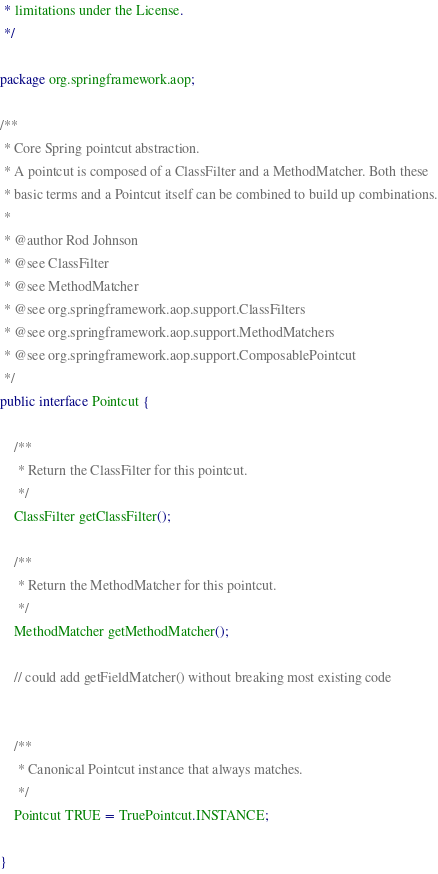<code> <loc_0><loc_0><loc_500><loc_500><_Java_> * limitations under the License.
 */

package org.springframework.aop;

/**
 * Core Spring pointcut abstraction.
 * A pointcut is composed of a ClassFilter and a MethodMatcher. Both these
 * basic terms and a Pointcut itself can be combined to build up combinations.
 *
 * @author Rod Johnson
 * @see ClassFilter
 * @see MethodMatcher
 * @see org.springframework.aop.support.ClassFilters
 * @see org.springframework.aop.support.MethodMatchers
 * @see org.springframework.aop.support.ComposablePointcut
 */
public interface Pointcut {

	/**
	 * Return the ClassFilter for this pointcut.
	 */
	ClassFilter getClassFilter();

	/**
	 * Return the MethodMatcher for this pointcut.
	 */
	MethodMatcher getMethodMatcher();

	// could add getFieldMatcher() without breaking most existing code


	/**
	 * Canonical Pointcut instance that always matches.
	 */
	Pointcut TRUE = TruePointcut.INSTANCE;

}
</code> 